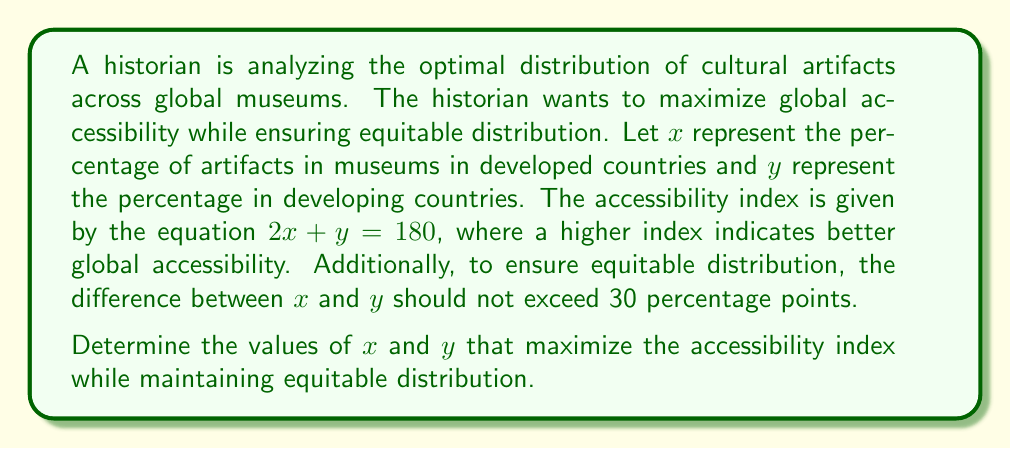Solve this math problem. To solve this problem, we'll follow these steps:

1) We have the main equation: $2x + y = 180$

2) For equitable distribution, the difference between $x$ and $y$ should not exceed 30:
   $-30 \leq x - y \leq 30$

3) Since we want to maximize the accessibility index (left side of the equation), we should make $x$ as large as possible while satisfying the constraints.

4) The maximum difference occurs when $x - y = 30$

5) Substituting $y = x - 30$ into the main equation:
   $2x + (x - 30) = 180$
   $3x - 30 = 180$
   $3x = 210$
   $x = 70$

6) Now we can find $y$:
   $y = x - 30 = 70 - 30 = 40$

7) Let's verify that this satisfies the main equation:
   $2(70) + 40 = 140 + 40 = 180$

Therefore, the optimal distribution is 70% in developed countries and 40% in developing countries.
Answer: $x = 70$, $y = 40$ 